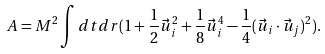Convert formula to latex. <formula><loc_0><loc_0><loc_500><loc_500>A = M ^ { 2 } \int d t d r ( 1 + \frac { 1 } { 2 } \vec { u } ^ { 2 } _ { i } + \frac { 1 } { 8 } \vec { u } ^ { 4 } _ { i } - \frac { 1 } { 4 } ( \vec { u } _ { i } \cdot \vec { u } _ { j } ) ^ { 2 } ) .</formula> 